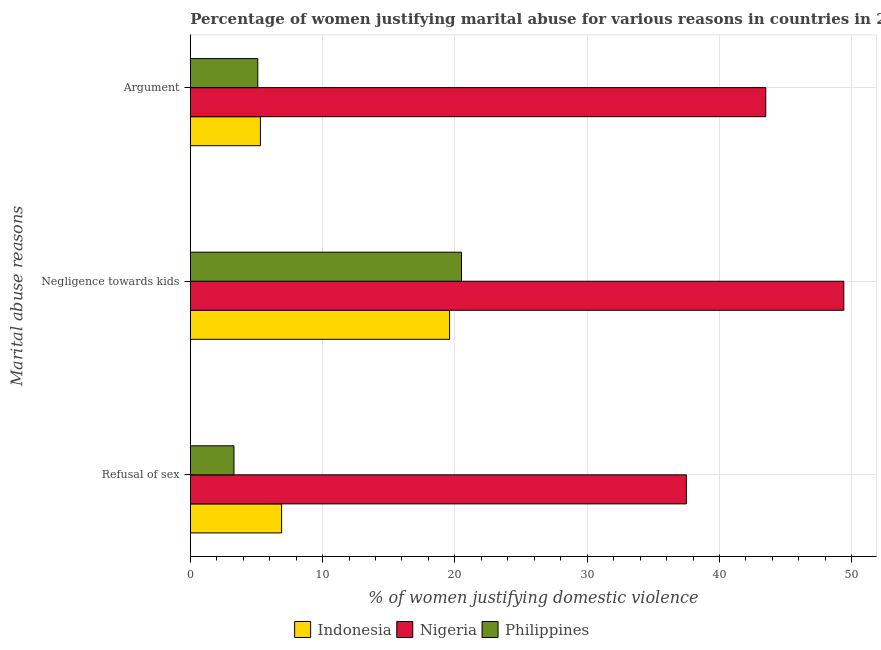How many different coloured bars are there?
Provide a short and direct response. 3. How many groups of bars are there?
Provide a succinct answer. 3. Are the number of bars per tick equal to the number of legend labels?
Provide a short and direct response. Yes. Are the number of bars on each tick of the Y-axis equal?
Provide a succinct answer. Yes. What is the label of the 3rd group of bars from the top?
Your answer should be very brief. Refusal of sex. What is the percentage of women justifying domestic violence due to refusal of sex in Philippines?
Your answer should be compact. 3.3. Across all countries, what is the maximum percentage of women justifying domestic violence due to negligence towards kids?
Ensure brevity in your answer.  49.4. In which country was the percentage of women justifying domestic violence due to refusal of sex maximum?
Provide a succinct answer. Nigeria. In which country was the percentage of women justifying domestic violence due to refusal of sex minimum?
Your answer should be very brief. Philippines. What is the total percentage of women justifying domestic violence due to negligence towards kids in the graph?
Give a very brief answer. 89.5. What is the difference between the percentage of women justifying domestic violence due to refusal of sex in Nigeria and that in Philippines?
Your response must be concise. 34.2. What is the average percentage of women justifying domestic violence due to refusal of sex per country?
Make the answer very short. 15.9. In how many countries, is the percentage of women justifying domestic violence due to refusal of sex greater than 22 %?
Your answer should be compact. 1. What is the ratio of the percentage of women justifying domestic violence due to refusal of sex in Nigeria to that in Indonesia?
Make the answer very short. 5.43. What is the difference between the highest and the second highest percentage of women justifying domestic violence due to arguments?
Provide a succinct answer. 38.2. What is the difference between the highest and the lowest percentage of women justifying domestic violence due to arguments?
Provide a short and direct response. 38.4. In how many countries, is the percentage of women justifying domestic violence due to negligence towards kids greater than the average percentage of women justifying domestic violence due to negligence towards kids taken over all countries?
Provide a succinct answer. 1. Is the sum of the percentage of women justifying domestic violence due to refusal of sex in Philippines and Nigeria greater than the maximum percentage of women justifying domestic violence due to arguments across all countries?
Your answer should be very brief. No. What does the 3rd bar from the top in Argument represents?
Ensure brevity in your answer.  Indonesia. What does the 2nd bar from the bottom in Refusal of sex represents?
Offer a terse response. Nigeria. How many countries are there in the graph?
Make the answer very short. 3. What is the difference between two consecutive major ticks on the X-axis?
Make the answer very short. 10. Are the values on the major ticks of X-axis written in scientific E-notation?
Ensure brevity in your answer.  No. Does the graph contain grids?
Ensure brevity in your answer.  Yes. Where does the legend appear in the graph?
Offer a very short reply. Bottom center. How many legend labels are there?
Ensure brevity in your answer.  3. How are the legend labels stacked?
Make the answer very short. Horizontal. What is the title of the graph?
Your answer should be very brief. Percentage of women justifying marital abuse for various reasons in countries in 2003. Does "Korea (Republic)" appear as one of the legend labels in the graph?
Offer a very short reply. No. What is the label or title of the X-axis?
Your response must be concise. % of women justifying domestic violence. What is the label or title of the Y-axis?
Your response must be concise. Marital abuse reasons. What is the % of women justifying domestic violence of Indonesia in Refusal of sex?
Your answer should be very brief. 6.9. What is the % of women justifying domestic violence in Nigeria in Refusal of sex?
Your response must be concise. 37.5. What is the % of women justifying domestic violence of Philippines in Refusal of sex?
Your response must be concise. 3.3. What is the % of women justifying domestic violence of Indonesia in Negligence towards kids?
Your response must be concise. 19.6. What is the % of women justifying domestic violence of Nigeria in Negligence towards kids?
Keep it short and to the point. 49.4. What is the % of women justifying domestic violence of Indonesia in Argument?
Your answer should be very brief. 5.3. What is the % of women justifying domestic violence in Nigeria in Argument?
Offer a very short reply. 43.5. What is the % of women justifying domestic violence in Philippines in Argument?
Your answer should be compact. 5.1. Across all Marital abuse reasons, what is the maximum % of women justifying domestic violence of Indonesia?
Provide a short and direct response. 19.6. Across all Marital abuse reasons, what is the maximum % of women justifying domestic violence in Nigeria?
Make the answer very short. 49.4. Across all Marital abuse reasons, what is the minimum % of women justifying domestic violence of Indonesia?
Offer a terse response. 5.3. Across all Marital abuse reasons, what is the minimum % of women justifying domestic violence of Nigeria?
Give a very brief answer. 37.5. What is the total % of women justifying domestic violence in Indonesia in the graph?
Your answer should be compact. 31.8. What is the total % of women justifying domestic violence in Nigeria in the graph?
Your response must be concise. 130.4. What is the total % of women justifying domestic violence of Philippines in the graph?
Offer a terse response. 28.9. What is the difference between the % of women justifying domestic violence in Indonesia in Refusal of sex and that in Negligence towards kids?
Your answer should be very brief. -12.7. What is the difference between the % of women justifying domestic violence of Philippines in Refusal of sex and that in Negligence towards kids?
Keep it short and to the point. -17.2. What is the difference between the % of women justifying domestic violence of Indonesia in Refusal of sex and that in Argument?
Give a very brief answer. 1.6. What is the difference between the % of women justifying domestic violence in Philippines in Refusal of sex and that in Argument?
Provide a succinct answer. -1.8. What is the difference between the % of women justifying domestic violence in Nigeria in Negligence towards kids and that in Argument?
Ensure brevity in your answer.  5.9. What is the difference between the % of women justifying domestic violence in Indonesia in Refusal of sex and the % of women justifying domestic violence in Nigeria in Negligence towards kids?
Ensure brevity in your answer.  -42.5. What is the difference between the % of women justifying domestic violence in Nigeria in Refusal of sex and the % of women justifying domestic violence in Philippines in Negligence towards kids?
Offer a terse response. 17. What is the difference between the % of women justifying domestic violence in Indonesia in Refusal of sex and the % of women justifying domestic violence in Nigeria in Argument?
Keep it short and to the point. -36.6. What is the difference between the % of women justifying domestic violence in Indonesia in Refusal of sex and the % of women justifying domestic violence in Philippines in Argument?
Provide a short and direct response. 1.8. What is the difference between the % of women justifying domestic violence in Nigeria in Refusal of sex and the % of women justifying domestic violence in Philippines in Argument?
Your answer should be very brief. 32.4. What is the difference between the % of women justifying domestic violence in Indonesia in Negligence towards kids and the % of women justifying domestic violence in Nigeria in Argument?
Your answer should be very brief. -23.9. What is the difference between the % of women justifying domestic violence in Indonesia in Negligence towards kids and the % of women justifying domestic violence in Philippines in Argument?
Ensure brevity in your answer.  14.5. What is the difference between the % of women justifying domestic violence in Nigeria in Negligence towards kids and the % of women justifying domestic violence in Philippines in Argument?
Ensure brevity in your answer.  44.3. What is the average % of women justifying domestic violence of Indonesia per Marital abuse reasons?
Provide a short and direct response. 10.6. What is the average % of women justifying domestic violence of Nigeria per Marital abuse reasons?
Your answer should be very brief. 43.47. What is the average % of women justifying domestic violence in Philippines per Marital abuse reasons?
Offer a terse response. 9.63. What is the difference between the % of women justifying domestic violence of Indonesia and % of women justifying domestic violence of Nigeria in Refusal of sex?
Your response must be concise. -30.6. What is the difference between the % of women justifying domestic violence in Nigeria and % of women justifying domestic violence in Philippines in Refusal of sex?
Offer a terse response. 34.2. What is the difference between the % of women justifying domestic violence of Indonesia and % of women justifying domestic violence of Nigeria in Negligence towards kids?
Offer a terse response. -29.8. What is the difference between the % of women justifying domestic violence of Nigeria and % of women justifying domestic violence of Philippines in Negligence towards kids?
Provide a succinct answer. 28.9. What is the difference between the % of women justifying domestic violence of Indonesia and % of women justifying domestic violence of Nigeria in Argument?
Keep it short and to the point. -38.2. What is the difference between the % of women justifying domestic violence in Nigeria and % of women justifying domestic violence in Philippines in Argument?
Provide a succinct answer. 38.4. What is the ratio of the % of women justifying domestic violence of Indonesia in Refusal of sex to that in Negligence towards kids?
Offer a terse response. 0.35. What is the ratio of the % of women justifying domestic violence in Nigeria in Refusal of sex to that in Negligence towards kids?
Offer a terse response. 0.76. What is the ratio of the % of women justifying domestic violence in Philippines in Refusal of sex to that in Negligence towards kids?
Offer a very short reply. 0.16. What is the ratio of the % of women justifying domestic violence in Indonesia in Refusal of sex to that in Argument?
Provide a short and direct response. 1.3. What is the ratio of the % of women justifying domestic violence in Nigeria in Refusal of sex to that in Argument?
Offer a terse response. 0.86. What is the ratio of the % of women justifying domestic violence of Philippines in Refusal of sex to that in Argument?
Provide a short and direct response. 0.65. What is the ratio of the % of women justifying domestic violence in Indonesia in Negligence towards kids to that in Argument?
Your response must be concise. 3.7. What is the ratio of the % of women justifying domestic violence of Nigeria in Negligence towards kids to that in Argument?
Your answer should be very brief. 1.14. What is the ratio of the % of women justifying domestic violence of Philippines in Negligence towards kids to that in Argument?
Keep it short and to the point. 4.02. What is the difference between the highest and the second highest % of women justifying domestic violence in Indonesia?
Ensure brevity in your answer.  12.7. What is the difference between the highest and the second highest % of women justifying domestic violence of Nigeria?
Offer a terse response. 5.9. What is the difference between the highest and the second highest % of women justifying domestic violence in Philippines?
Offer a terse response. 15.4. What is the difference between the highest and the lowest % of women justifying domestic violence in Indonesia?
Give a very brief answer. 14.3. 